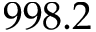<formula> <loc_0><loc_0><loc_500><loc_500>9 9 8 . 2</formula> 